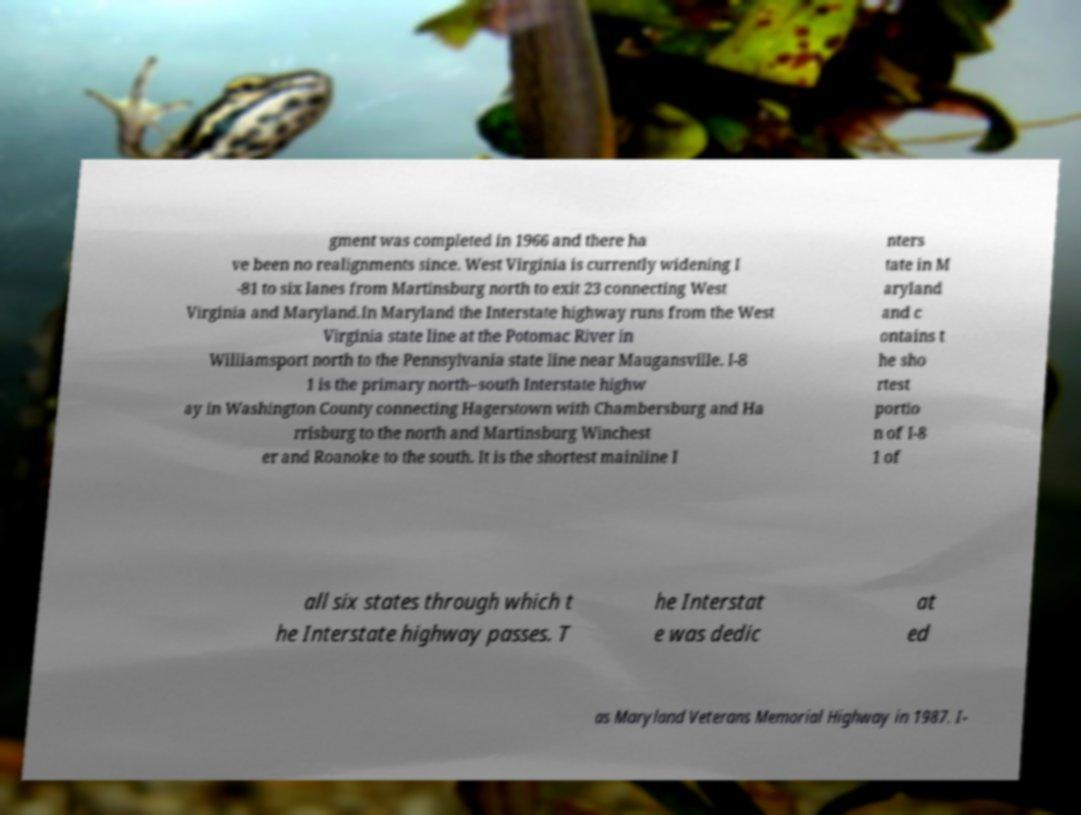Could you extract and type out the text from this image? gment was completed in 1966 and there ha ve been no realignments since. West Virginia is currently widening I -81 to six lanes from Martinsburg north to exit 23 connecting West Virginia and Maryland.In Maryland the Interstate highway runs from the West Virginia state line at the Potomac River in Williamsport north to the Pennsylvania state line near Maugansville. I-8 1 is the primary north–south Interstate highw ay in Washington County connecting Hagerstown with Chambersburg and Ha rrisburg to the north and Martinsburg Winchest er and Roanoke to the south. It is the shortest mainline I nters tate in M aryland and c ontains t he sho rtest portio n of I-8 1 of all six states through which t he Interstate highway passes. T he Interstat e was dedic at ed as Maryland Veterans Memorial Highway in 1987. I- 